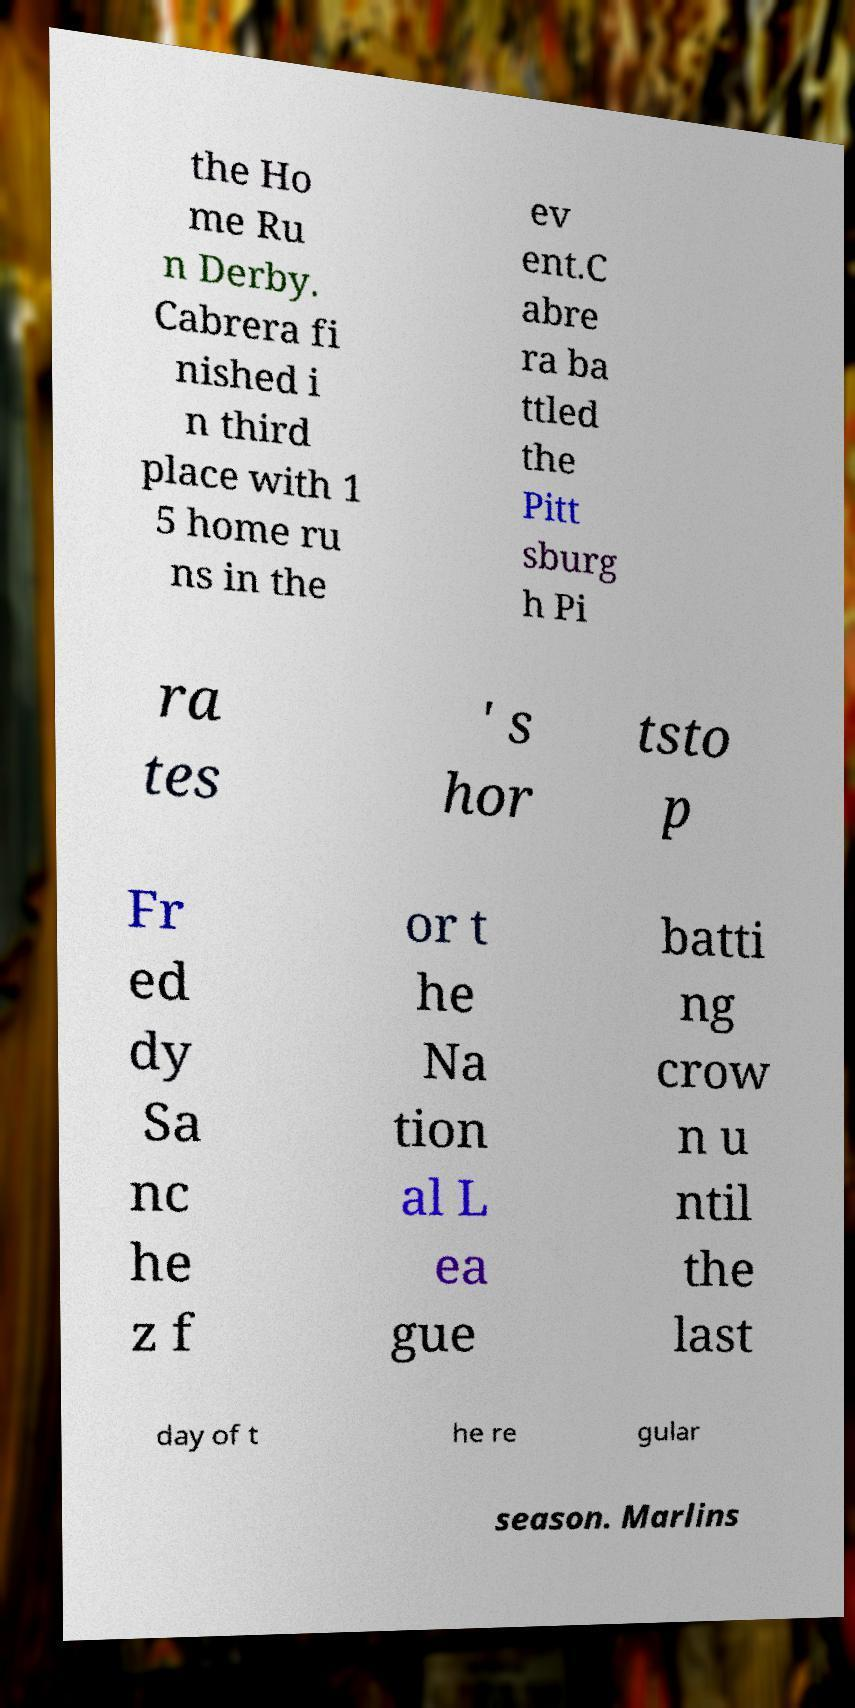I need the written content from this picture converted into text. Can you do that? the Ho me Ru n Derby. Cabrera fi nished i n third place with 1 5 home ru ns in the ev ent.C abre ra ba ttled the Pitt sburg h Pi ra tes ' s hor tsto p Fr ed dy Sa nc he z f or t he Na tion al L ea gue batti ng crow n u ntil the last day of t he re gular season. Marlins 